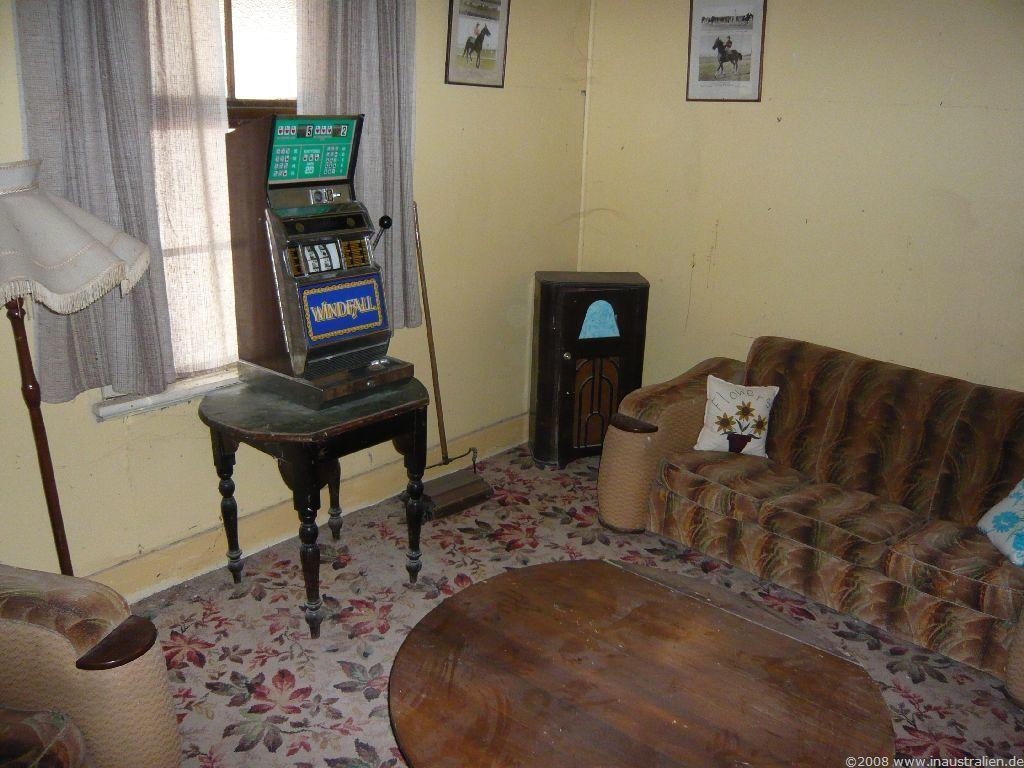What type of furniture is present in the image? There is a sofa with pillows in the image. What other objects can be seen in the room? There is a table, a lamp, a machine, and curtains on a window in the image. Are there any decorative elements in the room? Yes, there is a wall with frames in the image. What is the purpose of the stick in the image? The purpose of the stick in the image is not clear, but it could be used as a decorative item or for some other function. What type of feast is being prepared on the table in the image? There is no feast being prepared on the table in the image; it is a regular table with no food or cooking utensils visible. 